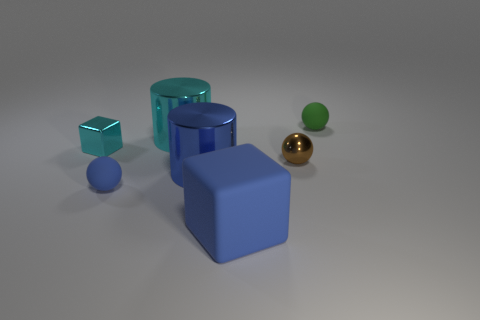How many shapes can you identify in this image and can you name them? In the image, I can identify five distinct shapes. There are two cubes - one cyan and one blue, two cylinders - one cyan and one blue, and finally two spheres - one green and one gold. Each object's geometry is clear and distinct against the neutral background. 